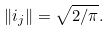Convert formula to latex. <formula><loc_0><loc_0><loc_500><loc_500>\| i _ { j } \| = \sqrt { 2 / \pi } .</formula> 